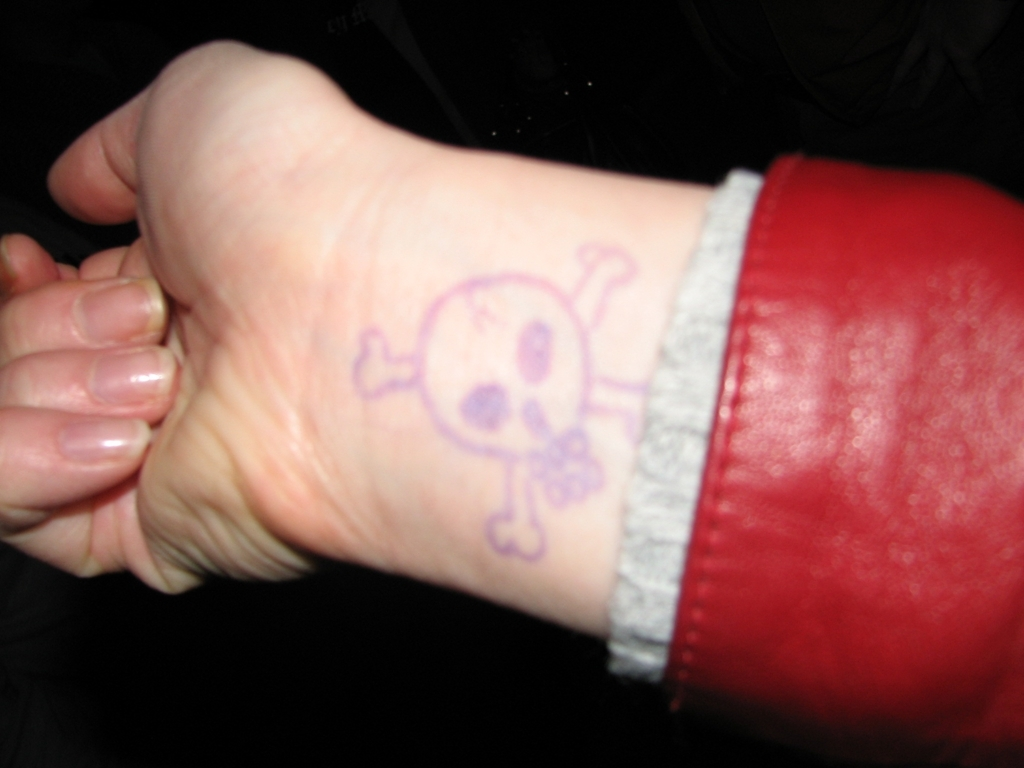Can you tell me more about the symbol on the wrist? The image displays a symbol resembling a skull and crossbones inked on the person's wrist. This image, historically associated with pirates, often conveys a sense of danger or serves as a warning sign. It's not clear from this image whether the symbol is a permanent tattoo or a temporary drawing. 